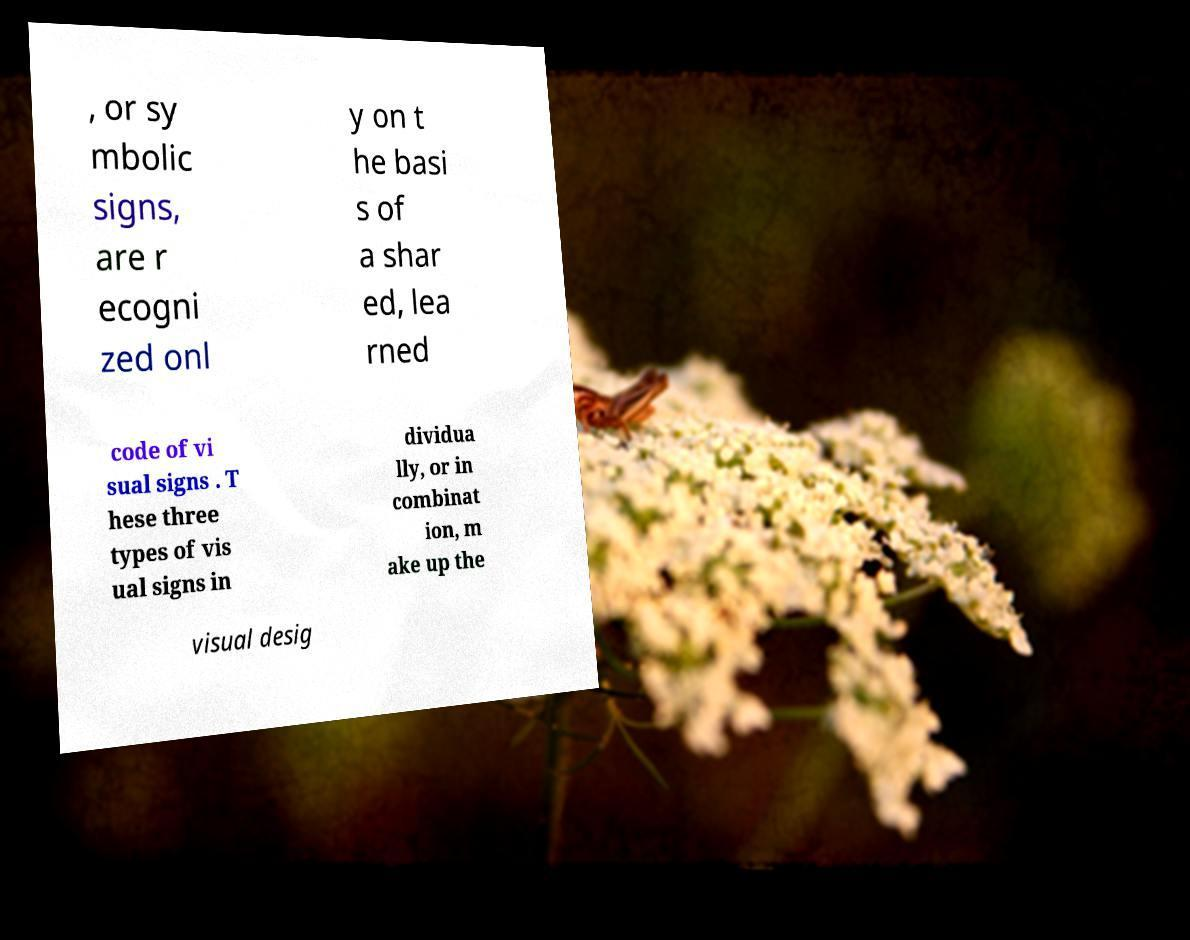Could you assist in decoding the text presented in this image and type it out clearly? , or sy mbolic signs, are r ecogni zed onl y on t he basi s of a shar ed, lea rned code of vi sual signs . T hese three types of vis ual signs in dividua lly, or in combinat ion, m ake up the visual desig 